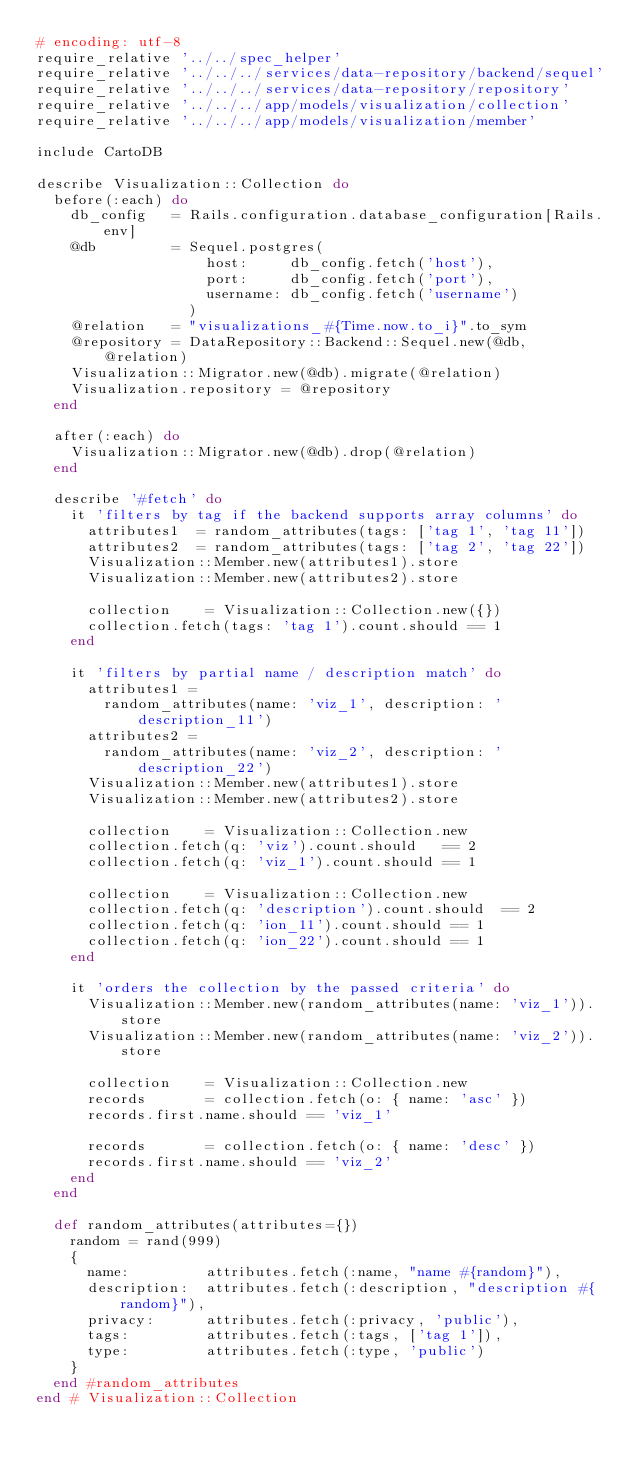Convert code to text. <code><loc_0><loc_0><loc_500><loc_500><_Ruby_># encoding: utf-8
require_relative '../../spec_helper'
require_relative '../../../services/data-repository/backend/sequel'
require_relative '../../../services/data-repository/repository'
require_relative '../../../app/models/visualization/collection'
require_relative '../../../app/models/visualization/member'

include CartoDB

describe Visualization::Collection do
  before(:each) do
    db_config   = Rails.configuration.database_configuration[Rails.env]
    @db         = Sequel.postgres(
                    host:     db_config.fetch('host'),
                    port:     db_config.fetch('port'),
                    username: db_config.fetch('username')
                  )
    @relation   = "visualizations_#{Time.now.to_i}".to_sym
    @repository = DataRepository::Backend::Sequel.new(@db, @relation)
    Visualization::Migrator.new(@db).migrate(@relation)
    Visualization.repository = @repository
  end

  after(:each) do
    Visualization::Migrator.new(@db).drop(@relation)
  end

  describe '#fetch' do
    it 'filters by tag if the backend supports array columns' do
      attributes1  = random_attributes(tags: ['tag 1', 'tag 11'])
      attributes2  = random_attributes(tags: ['tag 2', 'tag 22'])
      Visualization::Member.new(attributes1).store
      Visualization::Member.new(attributes2).store

      collection    = Visualization::Collection.new({})
      collection.fetch(tags: 'tag 1').count.should == 1
    end

    it 'filters by partial name / description match' do
      attributes1 =
        random_attributes(name: 'viz_1', description: 'description_11')
      attributes2 =
        random_attributes(name: 'viz_2', description: 'description_22')
      Visualization::Member.new(attributes1).store
      Visualization::Member.new(attributes2).store

      collection    = Visualization::Collection.new
      collection.fetch(q: 'viz').count.should   == 2
      collection.fetch(q: 'viz_1').count.should == 1

      collection    = Visualization::Collection.new
      collection.fetch(q: 'description').count.should  == 2
      collection.fetch(q: 'ion_11').count.should == 1
      collection.fetch(q: 'ion_22').count.should == 1
    end

    it 'orders the collection by the passed criteria' do
      Visualization::Member.new(random_attributes(name: 'viz_1')).store
      Visualization::Member.new(random_attributes(name: 'viz_2')).store

      collection    = Visualization::Collection.new
      records       = collection.fetch(o: { name: 'asc' })
      records.first.name.should == 'viz_1'

      records       = collection.fetch(o: { name: 'desc' })
      records.first.name.should == 'viz_2'
    end
  end

  def random_attributes(attributes={})
    random = rand(999)
    {
      name:         attributes.fetch(:name, "name #{random}"),
      description:  attributes.fetch(:description, "description #{random}"),
      privacy:      attributes.fetch(:privacy, 'public'),
      tags:         attributes.fetch(:tags, ['tag 1']),
      type:         attributes.fetch(:type, 'public')
    }
  end #random_attributes
end # Visualization::Collection

</code> 